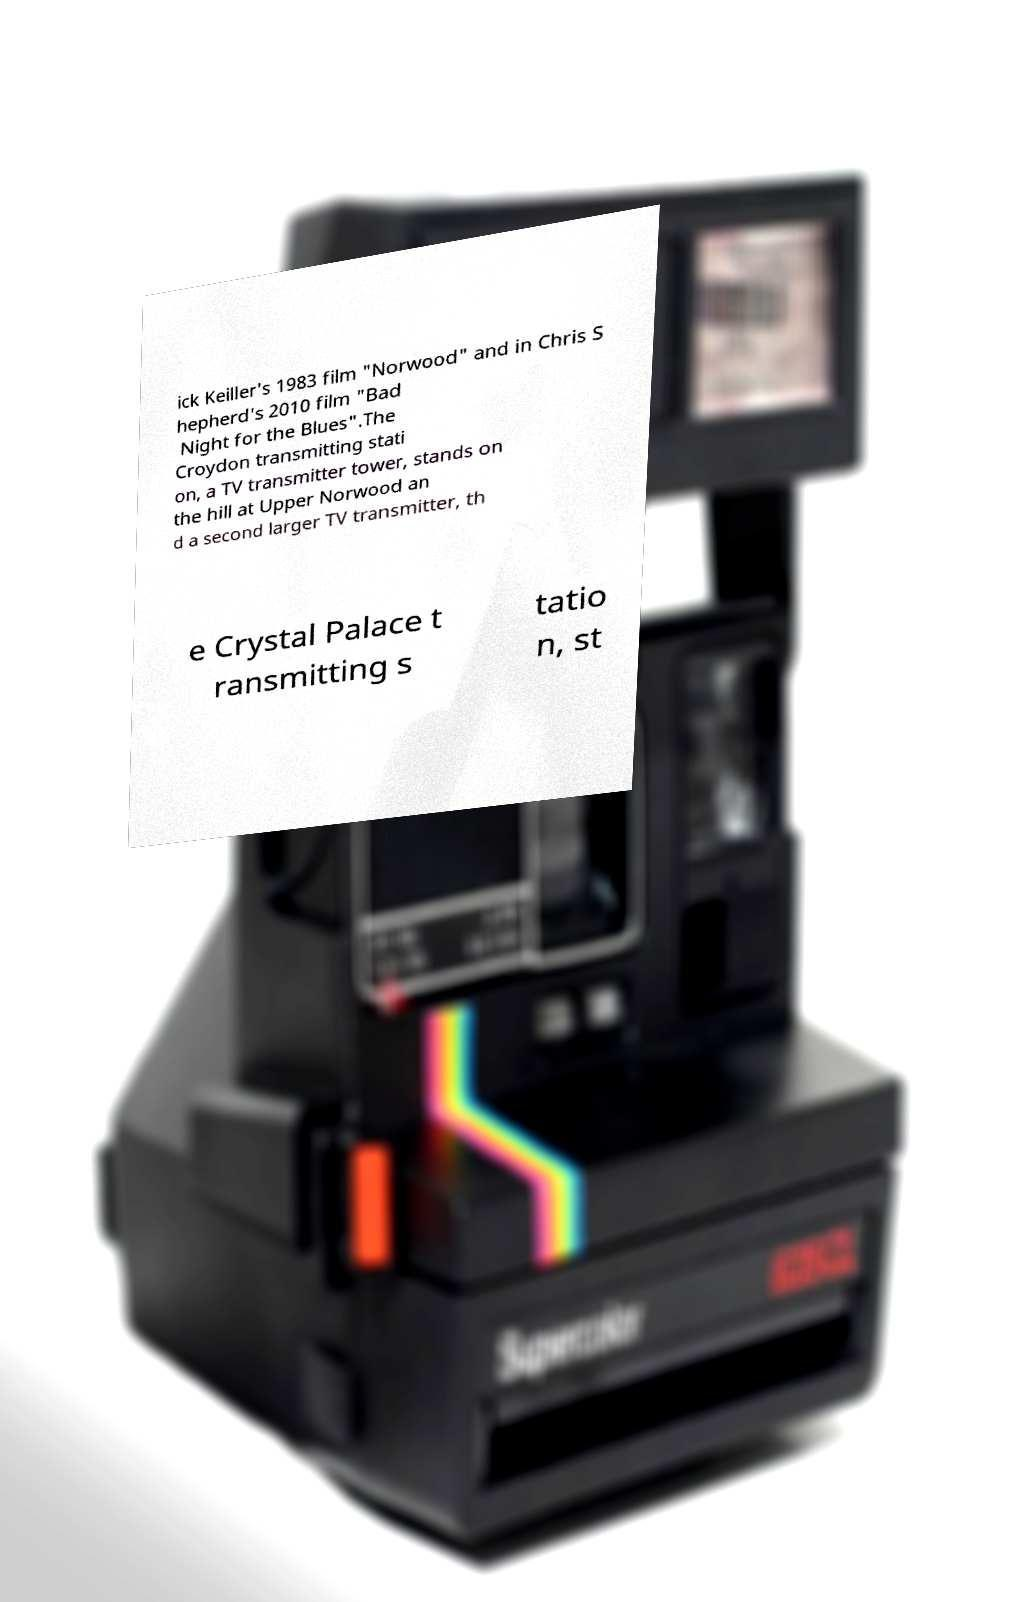Can you read and provide the text displayed in the image?This photo seems to have some interesting text. Can you extract and type it out for me? ick Keiller's 1983 film "Norwood" and in Chris S hepherd's 2010 film "Bad Night for the Blues".The Croydon transmitting stati on, a TV transmitter tower, stands on the hill at Upper Norwood an d a second larger TV transmitter, th e Crystal Palace t ransmitting s tatio n, st 